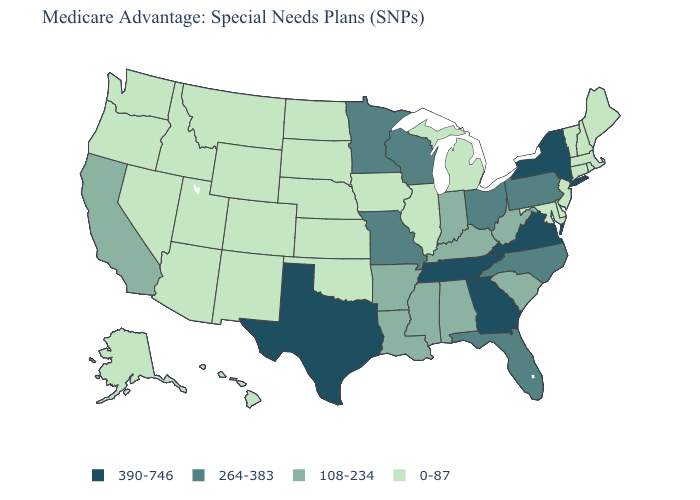Which states have the lowest value in the MidWest?
Be succinct. Illinois, Iowa, Kansas, Michigan, Nebraska, North Dakota, South Dakota. Among the states that border Tennessee , which have the highest value?
Quick response, please. Georgia, Virginia. What is the lowest value in states that border Nevada?
Concise answer only. 0-87. What is the value of Florida?
Keep it brief. 264-383. What is the value of Ohio?
Keep it brief. 264-383. Name the states that have a value in the range 0-87?
Concise answer only. Alaska, Arizona, Colorado, Connecticut, Delaware, Hawaii, Idaho, Illinois, Iowa, Kansas, Maine, Maryland, Massachusetts, Michigan, Montana, Nebraska, Nevada, New Hampshire, New Jersey, New Mexico, North Dakota, Oklahoma, Oregon, Rhode Island, South Dakota, Utah, Vermont, Washington, Wyoming. How many symbols are there in the legend?
Short answer required. 4. What is the value of Washington?
Be succinct. 0-87. Does Wisconsin have the same value as Louisiana?
Write a very short answer. No. What is the value of Colorado?
Keep it brief. 0-87. Is the legend a continuous bar?
Answer briefly. No. Name the states that have a value in the range 264-383?
Give a very brief answer. Florida, Minnesota, Missouri, North Carolina, Ohio, Pennsylvania, Wisconsin. Name the states that have a value in the range 108-234?
Be succinct. Alabama, Arkansas, California, Indiana, Kentucky, Louisiana, Mississippi, South Carolina, West Virginia. Does Arizona have a lower value than South Dakota?
Be succinct. No. Does Pennsylvania have the highest value in the Northeast?
Short answer required. No. 